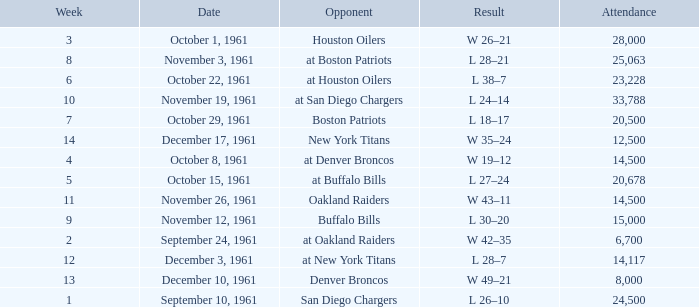What is the top attendance for weeks past 2 on october 29, 1961? 20500.0. 